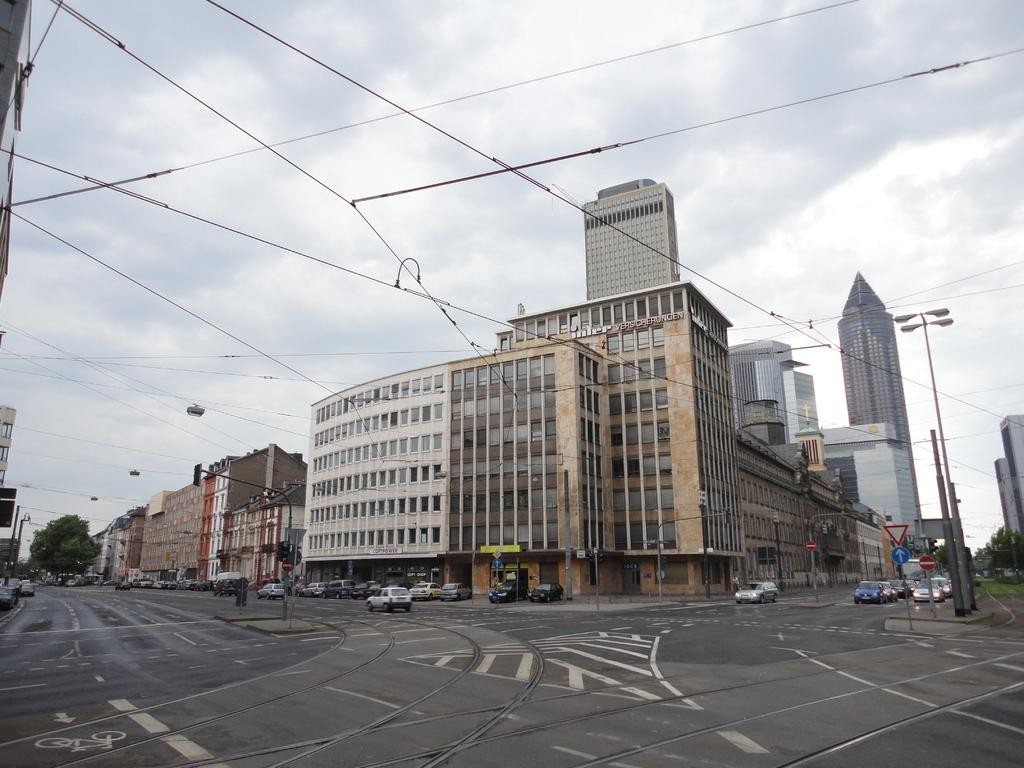What type of structures can be seen in the image? There are buildings in the image. What is happening on the road in the image? There are vehicles on the road in the image. What type of vegetation is present in the image? There are trees in the image. What else can be seen in the image that is related to infrastructure? There are wires, poles with lights, and sign boards in the image. What can be seen in the background of the image? The sky is visible in the background of the image. Can you tell me how many tents are set up in the image? There are no tents present in the image. What type of branch is hanging from the wires in the image? There are no branches hanging from the wires in the image. 